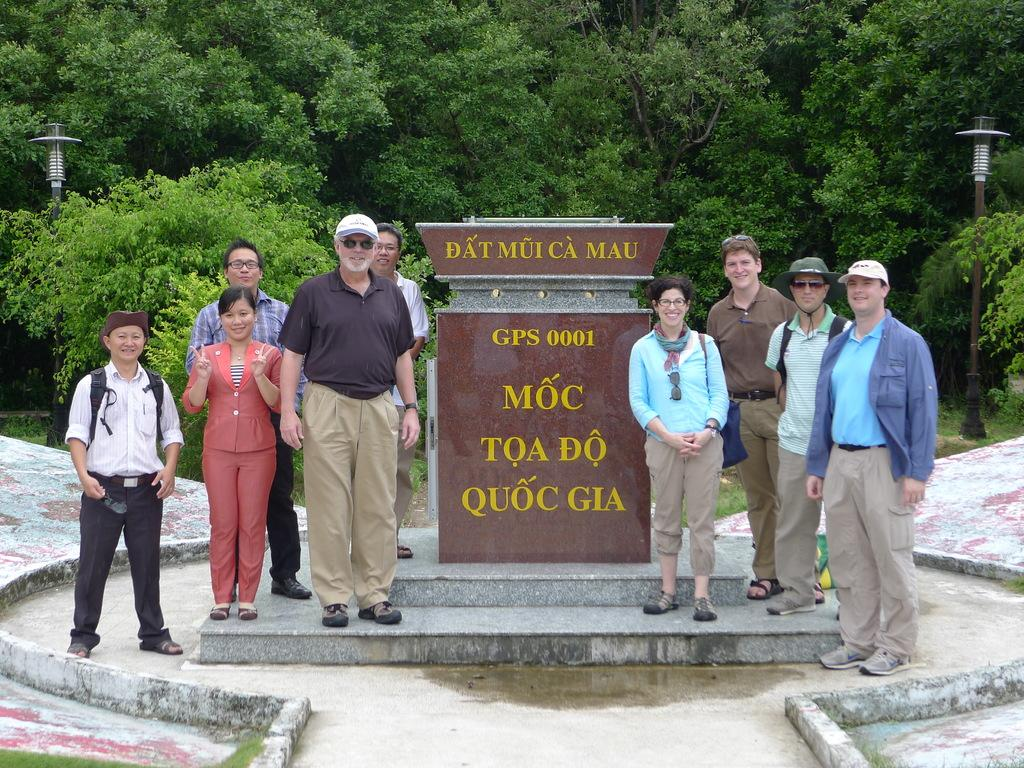What is the main subject in the center of the image? There is a large stone in the center of the image. What are the people near the stone doing? The people standing near the stone are not performing any specific action in the image. What can be seen in the background of the image? There are trees and poles visible in the background of the image. How many tomatoes are being harvested by the people near the stone? There are no tomatoes or harvesting activity present in the image. What type of road can be seen leading to the stone in the image? There is no road visible in the image; it only features a large stone, people, trees, and poles. 